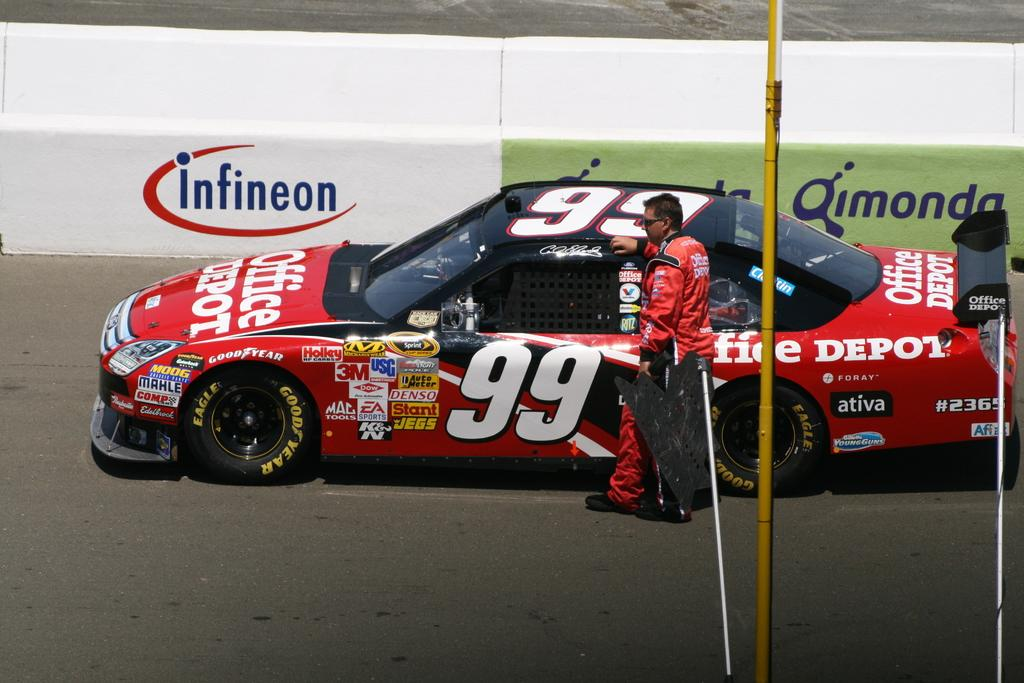What is the main subject of the picture? The main subject of the picture is a car. What is the man in the picture doing? The man is standing on the road. What can be seen on the car in the image? There are logos and writing on the car, and logos are also visible in the image. What else can be seen in the picture besides the car and the man? There are poles and other objects in the image. How many family members are visible in the image? There is no family present in the image; it only features a car and a man standing on the road. What type of fan is being used by the man in the image? There is no fan visible in the image. 